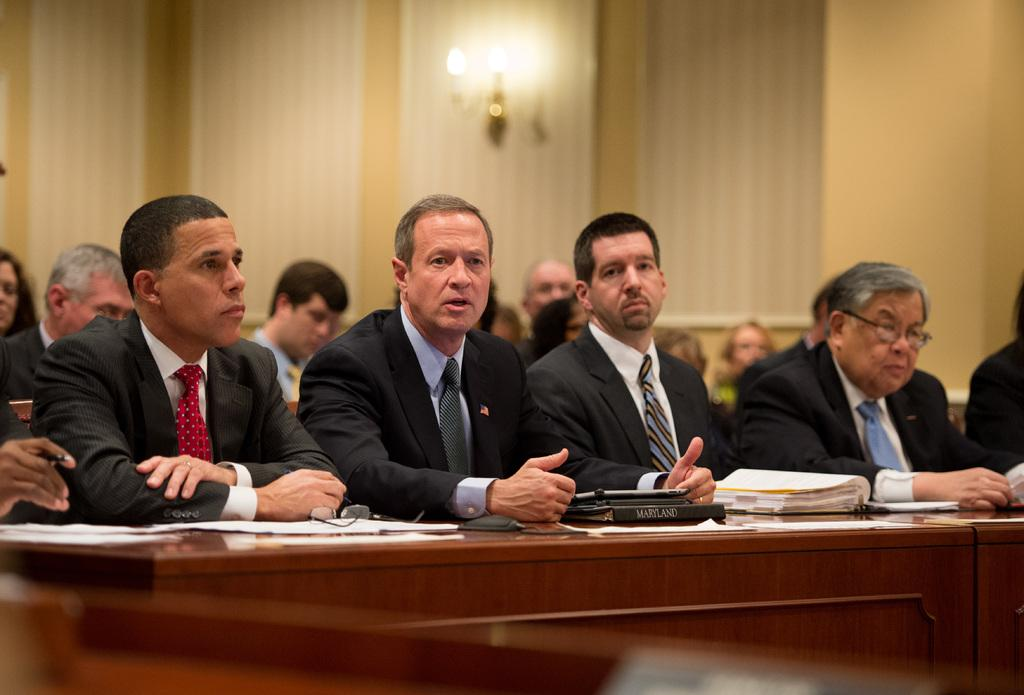Who or what is present in the image? There are people in the image. What can be seen on the table in the image? The objects on the table include posters and spectacles. Can you describe the object at the bottom of the image? There is an object at the bottom of the image, but its description is not provided in the facts. What is visible in the background of the image? There is a wall visible in the image. What type of illumination is present in the image? There is a light in the image. What is the tendency of the objects to cover the wall in the image? There is no indication in the image that the objects have a tendency to cover the wall. 